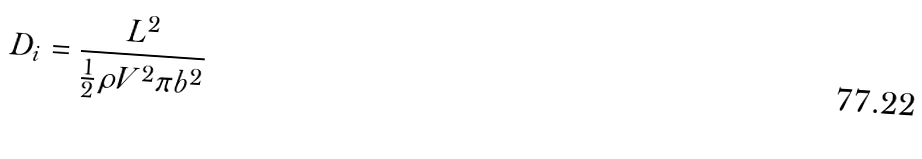<formula> <loc_0><loc_0><loc_500><loc_500>D _ { i } = { \frac { L ^ { 2 } } { { \frac { 1 } { 2 } } \rho V ^ { 2 } \pi b ^ { 2 } } }</formula> 